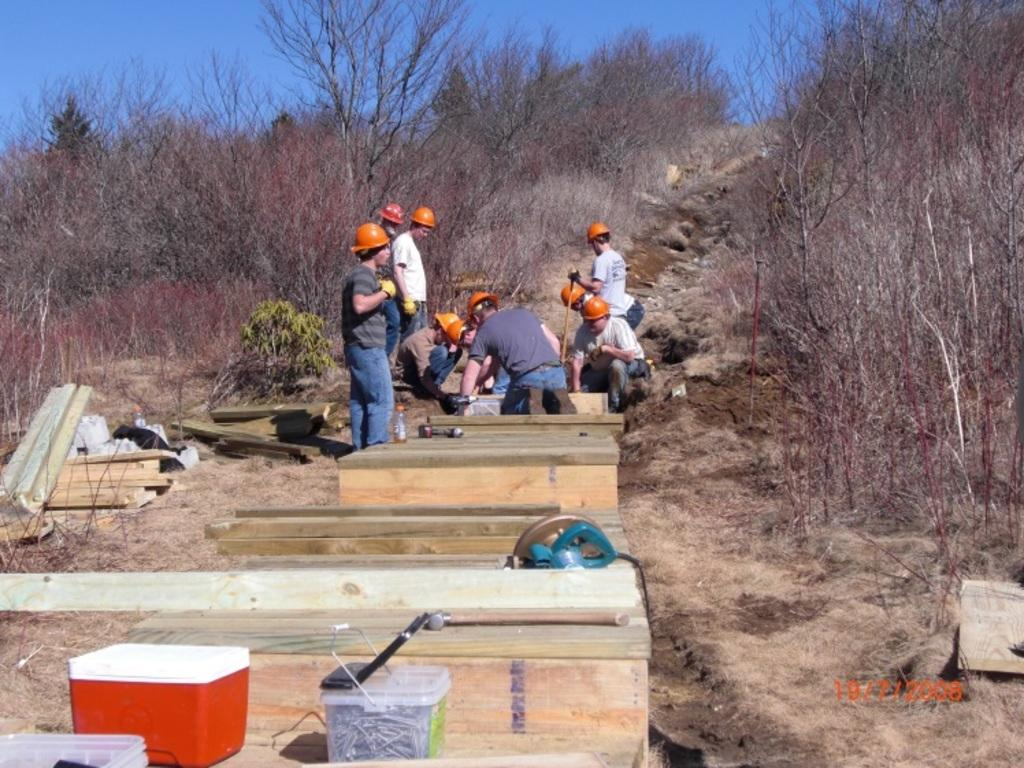What type of objects can be seen in the image? There are boxes and wooden objects in the image. What are the people wearing in the image? The people in the image are wearing helmets. What is located beside the people in the image? There are trees beside the people. What is the color of the sky in the image? The sky is blue in color. Can you locate the map in the image? There is no map present in the image. What type of range can be seen in the image? There is no range visible in the image. 